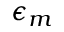<formula> <loc_0><loc_0><loc_500><loc_500>\epsilon _ { m }</formula> 